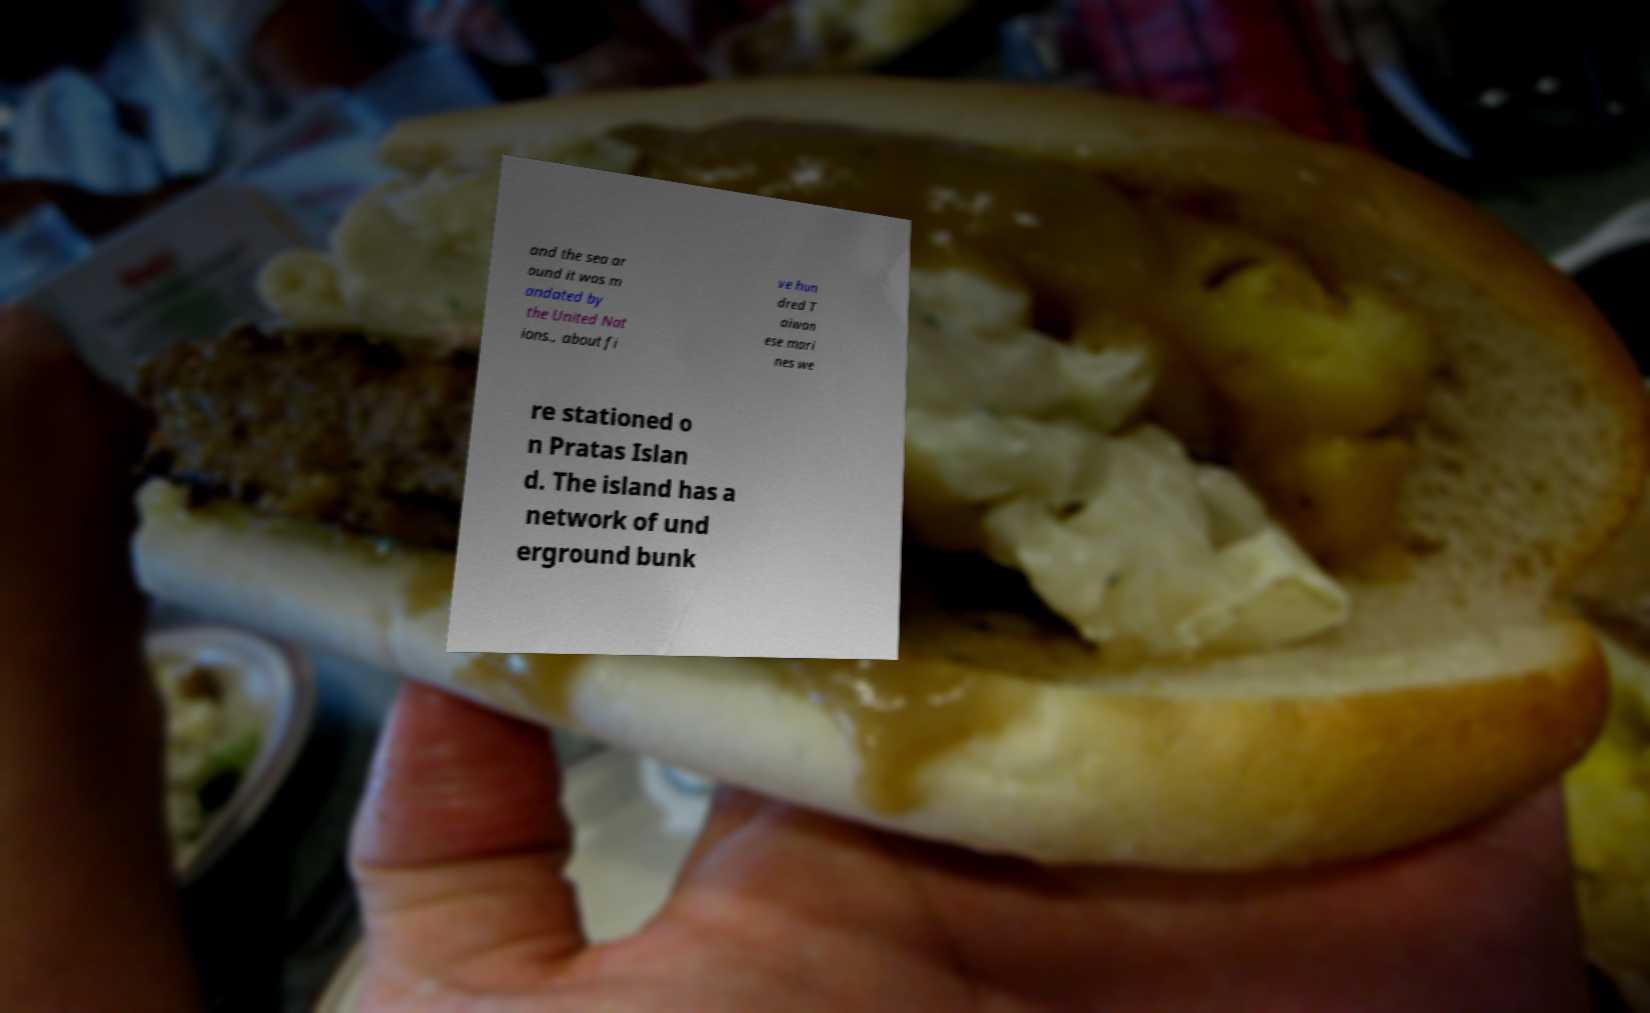Could you extract and type out the text from this image? and the sea ar ound it was m andated by the United Nat ions., about fi ve hun dred T aiwan ese mari nes we re stationed o n Pratas Islan d. The island has a network of und erground bunk 